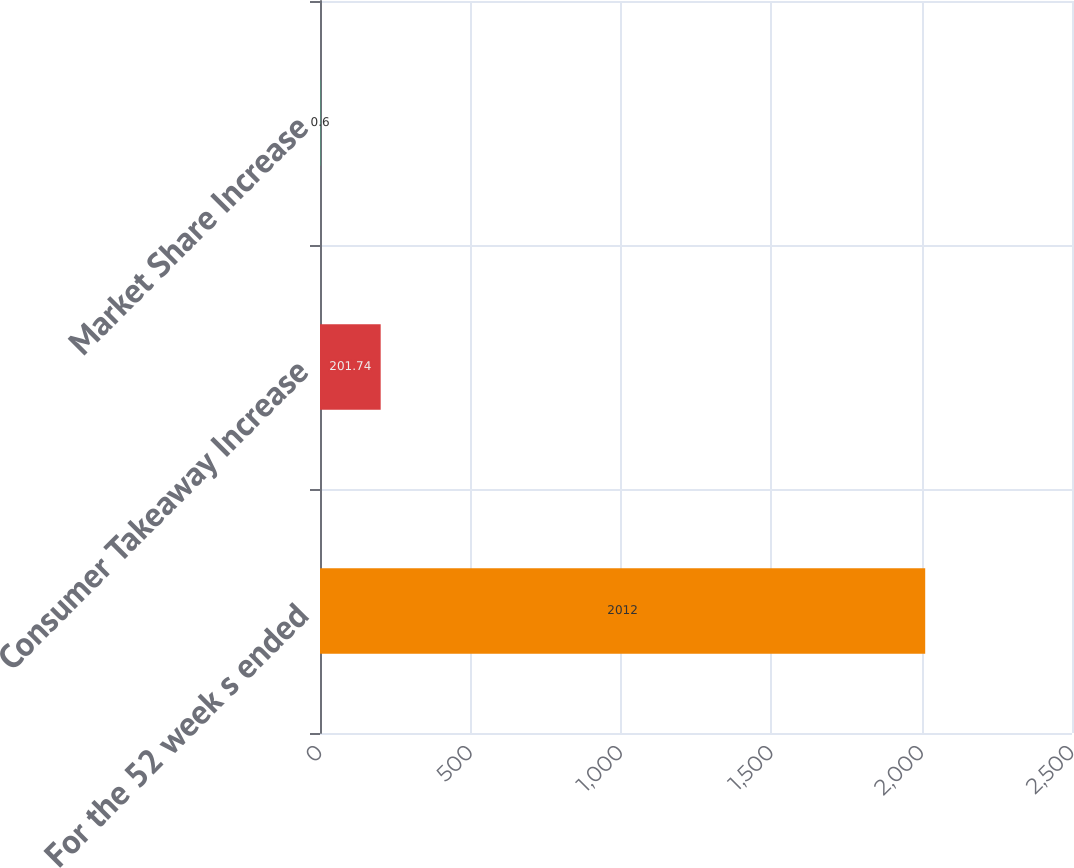<chart> <loc_0><loc_0><loc_500><loc_500><bar_chart><fcel>For the 52 week s ended<fcel>Consumer Takeaway Increase<fcel>Market Share Increase<nl><fcel>2012<fcel>201.74<fcel>0.6<nl></chart> 